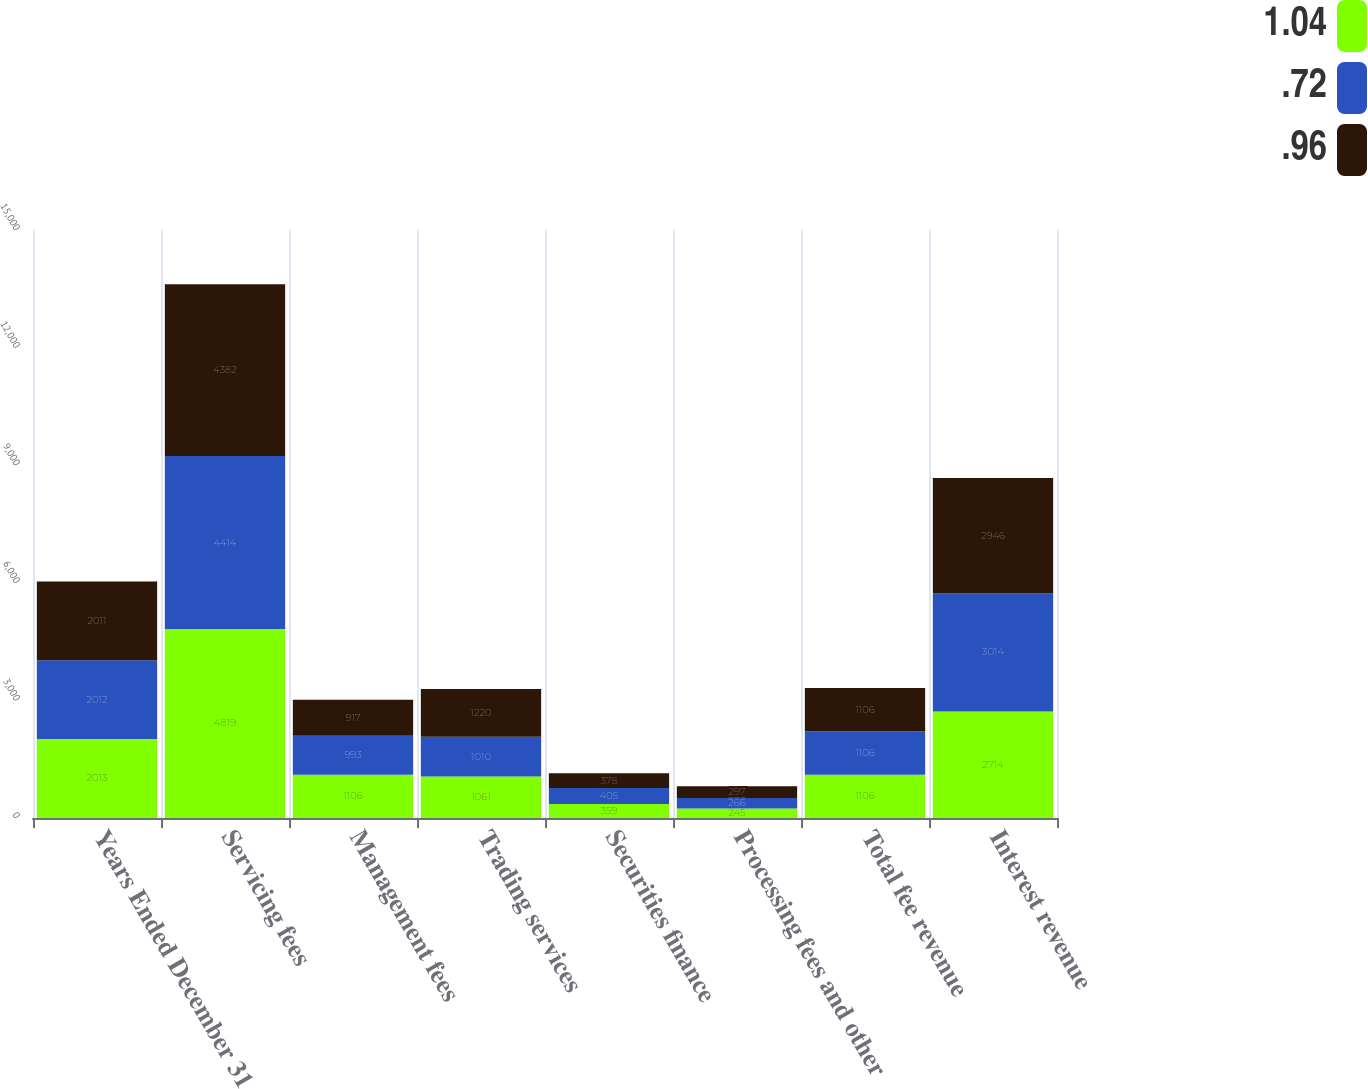<chart> <loc_0><loc_0><loc_500><loc_500><stacked_bar_chart><ecel><fcel>Years Ended December 31<fcel>Servicing fees<fcel>Management fees<fcel>Trading services<fcel>Securities finance<fcel>Processing fees and other<fcel>Total fee revenue<fcel>Interest revenue<nl><fcel>1.04<fcel>2013<fcel>4819<fcel>1106<fcel>1061<fcel>359<fcel>245<fcel>1106<fcel>2714<nl><fcel>0.72<fcel>2012<fcel>4414<fcel>993<fcel>1010<fcel>405<fcel>266<fcel>1106<fcel>3014<nl><fcel>0.96<fcel>2011<fcel>4382<fcel>917<fcel>1220<fcel>378<fcel>297<fcel>1106<fcel>2946<nl></chart> 